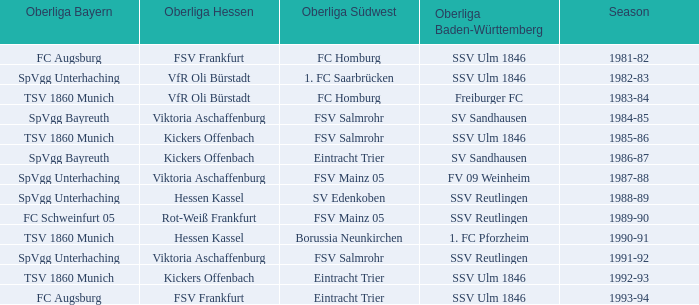Which oberliga baden-württemberg possesses a 1991-92 duration? SSV Reutlingen. Help me parse the entirety of this table. {'header': ['Oberliga Bayern', 'Oberliga Hessen', 'Oberliga Südwest', 'Oberliga Baden-Württemberg', 'Season'], 'rows': [['FC Augsburg', 'FSV Frankfurt', 'FC Homburg', 'SSV Ulm 1846', '1981-82'], ['SpVgg Unterhaching', 'VfR Oli Bürstadt', '1. FC Saarbrücken', 'SSV Ulm 1846', '1982-83'], ['TSV 1860 Munich', 'VfR Oli Bürstadt', 'FC Homburg', 'Freiburger FC', '1983-84'], ['SpVgg Bayreuth', 'Viktoria Aschaffenburg', 'FSV Salmrohr', 'SV Sandhausen', '1984-85'], ['TSV 1860 Munich', 'Kickers Offenbach', 'FSV Salmrohr', 'SSV Ulm 1846', '1985-86'], ['SpVgg Bayreuth', 'Kickers Offenbach', 'Eintracht Trier', 'SV Sandhausen', '1986-87'], ['SpVgg Unterhaching', 'Viktoria Aschaffenburg', 'FSV Mainz 05', 'FV 09 Weinheim', '1987-88'], ['SpVgg Unterhaching', 'Hessen Kassel', 'SV Edenkoben', 'SSV Reutlingen', '1988-89'], ['FC Schweinfurt 05', 'Rot-Weiß Frankfurt', 'FSV Mainz 05', 'SSV Reutlingen', '1989-90'], ['TSV 1860 Munich', 'Hessen Kassel', 'Borussia Neunkirchen', '1. FC Pforzheim', '1990-91'], ['SpVgg Unterhaching', 'Viktoria Aschaffenburg', 'FSV Salmrohr', 'SSV Reutlingen', '1991-92'], ['TSV 1860 Munich', 'Kickers Offenbach', 'Eintracht Trier', 'SSV Ulm 1846', '1992-93'], ['FC Augsburg', 'FSV Frankfurt', 'Eintracht Trier', 'SSV Ulm 1846', '1993-94']]} 